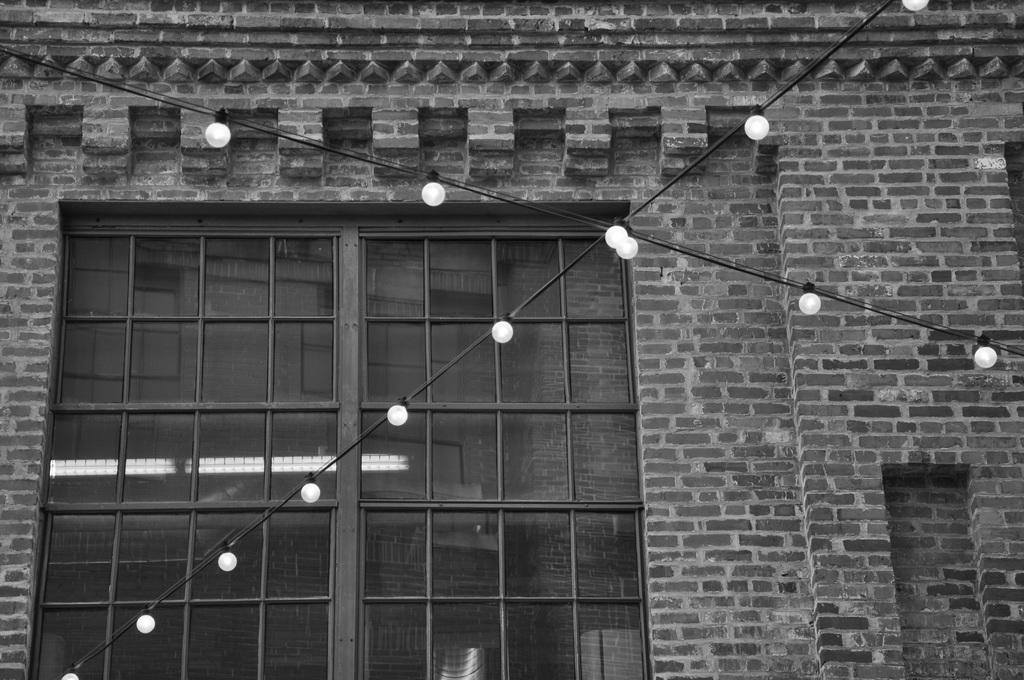What type of structure is visible in the image? There is a building in the image. What feature of the building is mentioned in the facts? The building has a wall. What can be found on the wall? There is a door and carvings on the wall. What else is present in the middle of the image? There are wires and lights in the middle of the image. What type of food is being served by the giraffe in the image? There is no giraffe present in the image, and therefore no food is being served. What material is the plastic used for in the image? There is no plastic mentioned or visible in the image. 